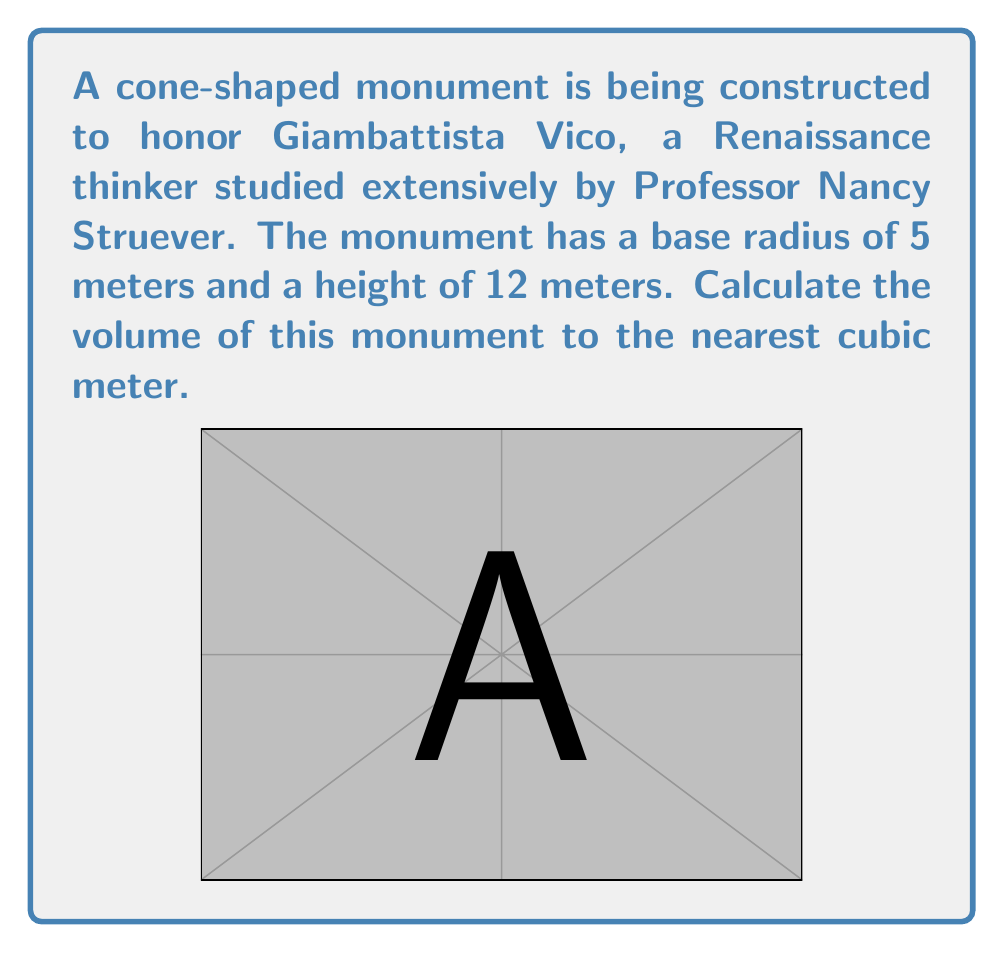Teach me how to tackle this problem. To find the volume of a cone, we use the formula:

$$V = \frac{1}{3}\pi r^2 h$$

Where:
$V$ = volume
$r$ = radius of the base
$h$ = height of the cone

Given:
$r = 5$ meters
$h = 12$ meters

Let's substitute these values into the formula:

$$V = \frac{1}{3}\pi (5\text{ m})^2 (12\text{ m})$$

$$V = \frac{1}{3}\pi (25\text{ m}^2) (12\text{ m})$$

$$V = 100\pi\text{ m}^3$$

Now, let's calculate this value:

$$V \approx 100 * 3.14159 \text{ m}^3$$

$$V \approx 314.159 \text{ m}^3$$

Rounding to the nearest cubic meter:

$$V \approx 314 \text{ m}^3$$
Answer: The volume of the cone-shaped monument is approximately 314 cubic meters. 